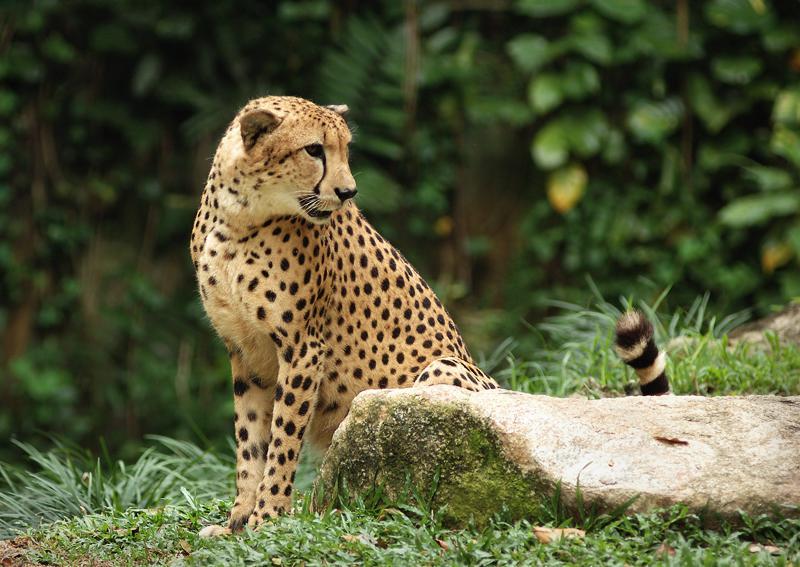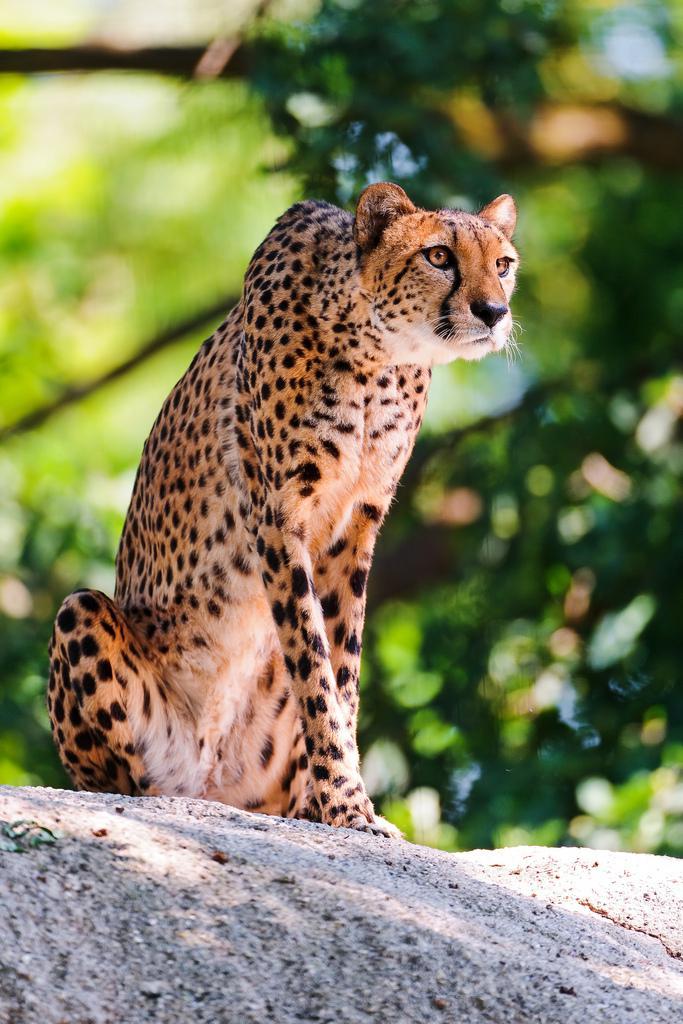The first image is the image on the left, the second image is the image on the right. Considering the images on both sides, is "There is exactly one cheetah sitting on a rock." valid? Answer yes or no. Yes. 